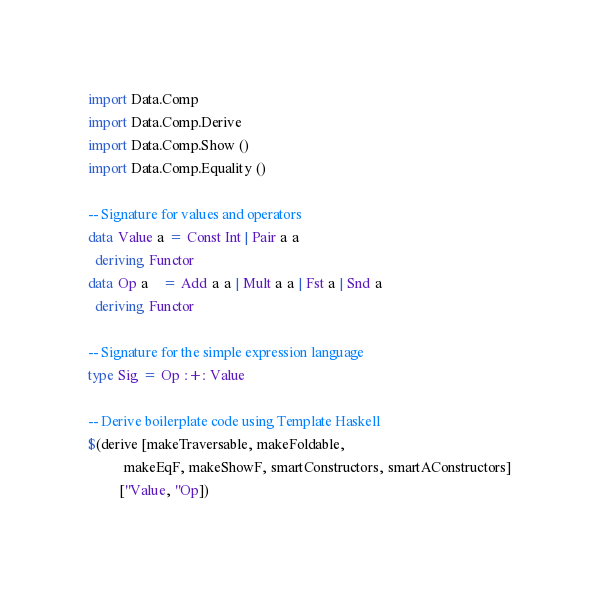Convert code to text. <code><loc_0><loc_0><loc_500><loc_500><_Haskell_>
import Data.Comp
import Data.Comp.Derive
import Data.Comp.Show ()
import Data.Comp.Equality ()

-- Signature for values and operators
data Value a = Const Int | Pair a a
  deriving Functor
data Op a    = Add a a | Mult a a | Fst a | Snd a
  deriving Functor

-- Signature for the simple expression language
type Sig = Op :+: Value

-- Derive boilerplate code using Template Haskell
$(derive [makeTraversable, makeFoldable,
          makeEqF, makeShowF, smartConstructors, smartAConstructors]
         [''Value, ''Op])
</code> 